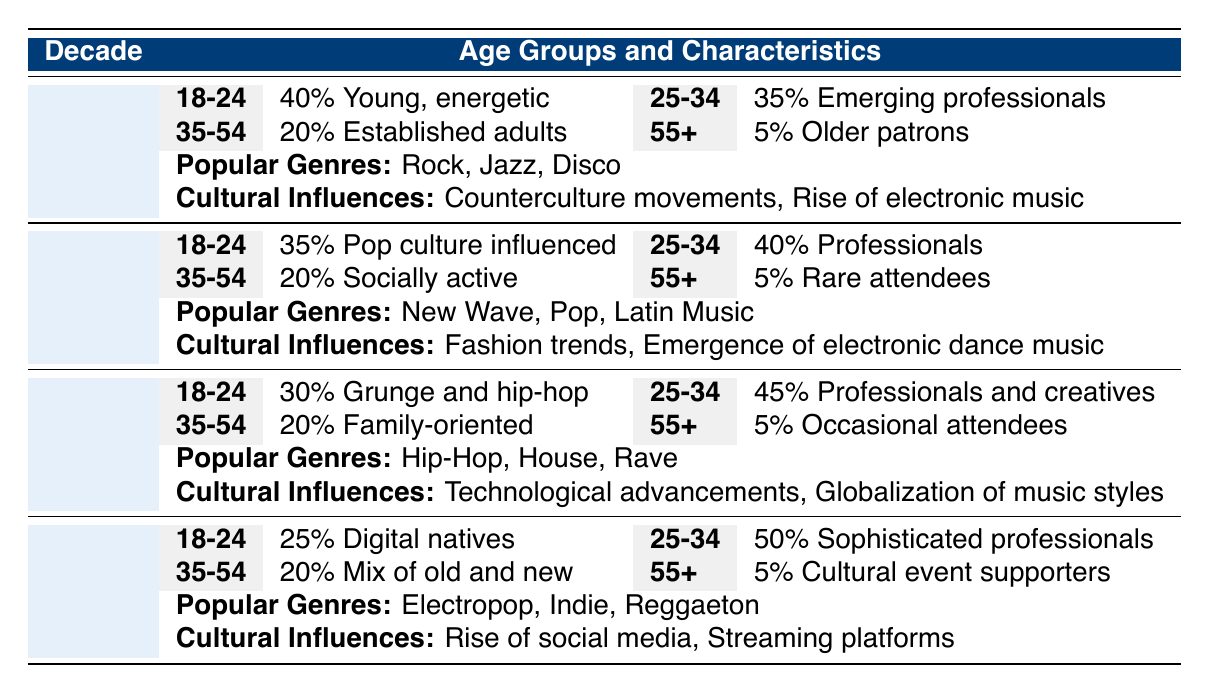What percentage of patrons in the 1990s were between 25 and 34 years old? In the 1990s, the percentage of patrons in the age group 25-34 is specified in the table as 45%.
Answer: 45% What popular music genre emerged in the 1980s? The popular music genres listed for the 1980s in the table include New Wave, Pop, and Latin Music, indicating the emergence of these styles during that decade.
Answer: New Wave, Pop, Latin Music Did the percentage of 18-24 year old patrons increase or decrease from the 1970s to the 2000s? In the 1970s, the percentage of patrons aged 18-24 was 40%, which decreased to 25% in the 2000s, showing a decline over the decades.
Answer: Decrease What was the average percentage of patrons aged 55 and older across all decades? The percentages for the age group 55+ are 5% for the 1970s, 5% for the 1980s, 5% for the 1990s, and 5% for the 2000s. Summing these gives a total of 20%, and dividing by the 4 decades gives an average of 20%/4 = 5%.
Answer: 5% Which decade had the highest percentage of patrons aged 25-34? The table shows 50% of patrons aged 25-34 in the 2000s, which is higher compared to 40% in the 1980s, 35% in the 1970s, and 45% in the 1990s, making the 2000s the highest.
Answer: 2000s What are the cultural influences in the 1970s? The table lists the cultural influences for the 1970s as "Counterculture movements" and "Rise of electronic music" indicating the societal trends during that decade, which shaped the patron demographics.
Answer: Counterculture movements, Rise of electronic music How did the characteristics of the 35-54 year-old patrons change from the 1970s to the 2000s? In the 1970s, the characteristics of this age group described them as "Established adults, mixing leisure with socializing," while in the 2000s, they were described as "Socially active, looking for a mix of old and new," suggesting a shift in their social engagement and interests.
Answer: Shift in social engagement Is there a trend of increasing sophistication in the characteristics of the 25-34 age group from the 1970s to the 2000s? Analyzing the characteristics, in the 1970s they were "Emerging professionals," and by the 2000s, they are described as "Professionals seeking sophisticated nightlife," indicating a trend towards increased sophistication over the decades.
Answer: Yes 